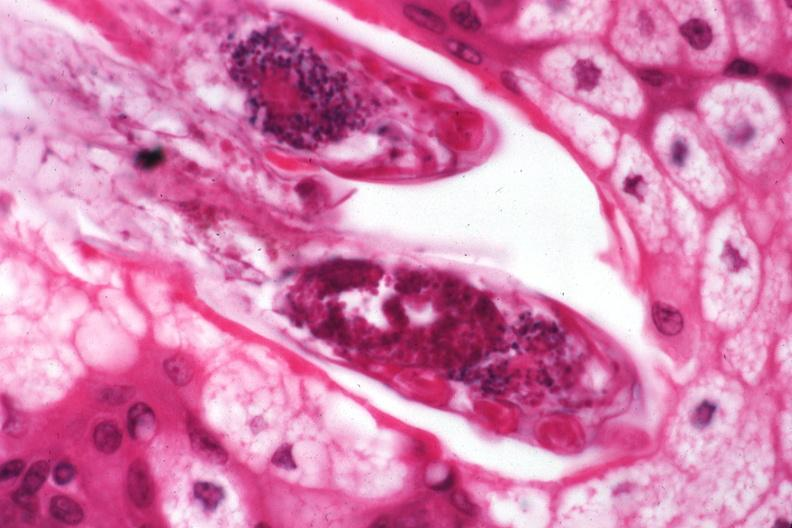where is this?
Answer the question using a single word or phrase. Skin 